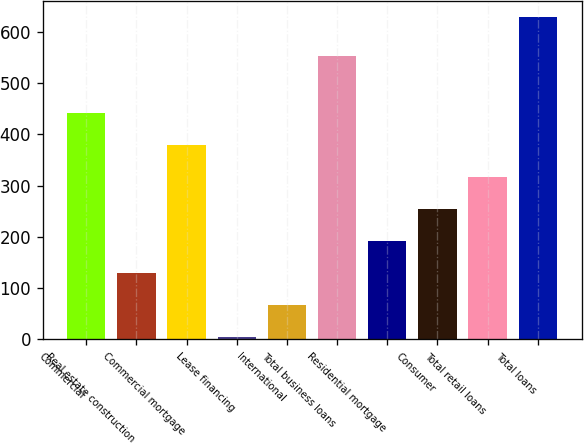<chart> <loc_0><loc_0><loc_500><loc_500><bar_chart><fcel>Commercial<fcel>Real estate construction<fcel>Commercial mortgage<fcel>Lease financing<fcel>International<fcel>Total business loans<fcel>Residential mortgage<fcel>Consumer<fcel>Total retail loans<fcel>Total loans<nl><fcel>441.5<fcel>129<fcel>379<fcel>4<fcel>66.5<fcel>552<fcel>191.5<fcel>254<fcel>316.5<fcel>629<nl></chart> 